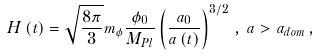Convert formula to latex. <formula><loc_0><loc_0><loc_500><loc_500>H \left ( t \right ) = \sqrt { \frac { 8 \pi } { 3 } } m _ { \phi } \frac { \phi _ { 0 } } { M _ { P l } } \left ( \frac { a _ { 0 } } { a \left ( t \right ) } \right ) ^ { 3 / 2 } \, , \, a > a _ { d o m } \, ,</formula> 